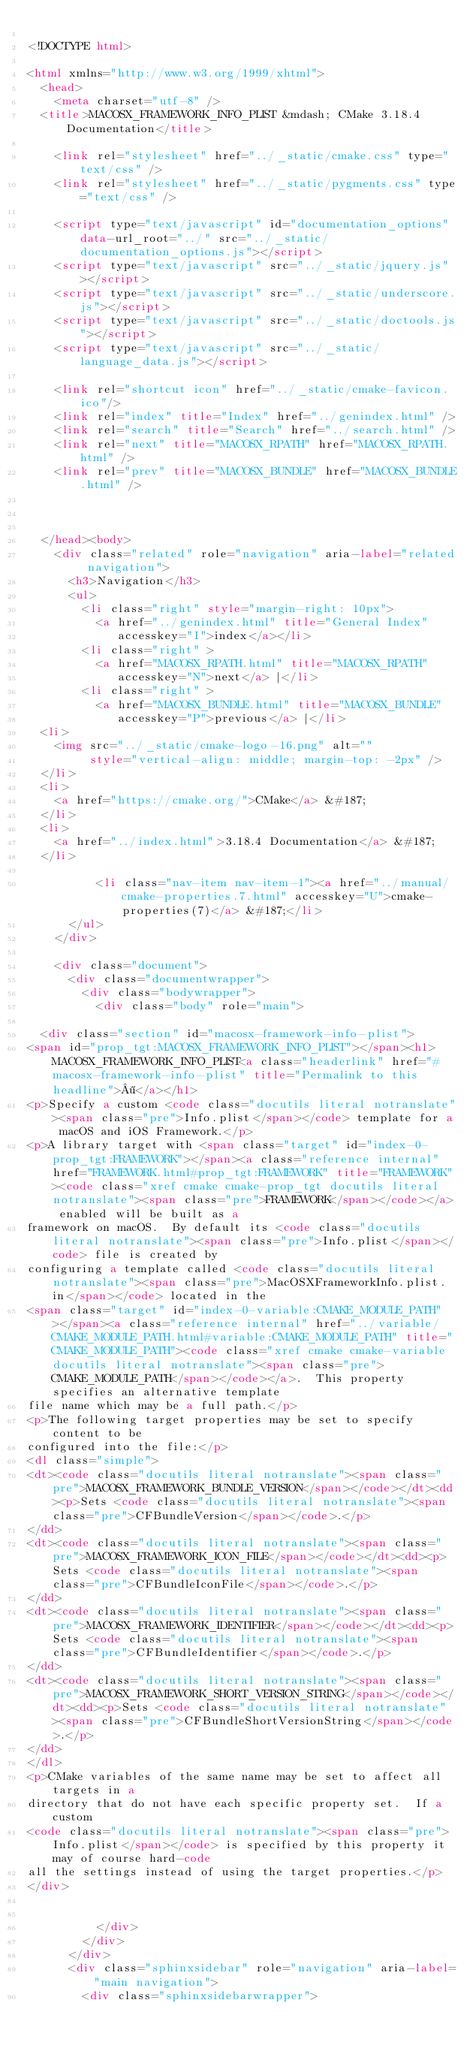Convert code to text. <code><loc_0><loc_0><loc_500><loc_500><_HTML_>
<!DOCTYPE html>

<html xmlns="http://www.w3.org/1999/xhtml">
  <head>
    <meta charset="utf-8" />
  <title>MACOSX_FRAMEWORK_INFO_PLIST &mdash; CMake 3.18.4 Documentation</title>

    <link rel="stylesheet" href="../_static/cmake.css" type="text/css" />
    <link rel="stylesheet" href="../_static/pygments.css" type="text/css" />
    
    <script type="text/javascript" id="documentation_options" data-url_root="../" src="../_static/documentation_options.js"></script>
    <script type="text/javascript" src="../_static/jquery.js"></script>
    <script type="text/javascript" src="../_static/underscore.js"></script>
    <script type="text/javascript" src="../_static/doctools.js"></script>
    <script type="text/javascript" src="../_static/language_data.js"></script>
    
    <link rel="shortcut icon" href="../_static/cmake-favicon.ico"/>
    <link rel="index" title="Index" href="../genindex.html" />
    <link rel="search" title="Search" href="../search.html" />
    <link rel="next" title="MACOSX_RPATH" href="MACOSX_RPATH.html" />
    <link rel="prev" title="MACOSX_BUNDLE" href="MACOSX_BUNDLE.html" />
  
 

  </head><body>
    <div class="related" role="navigation" aria-label="related navigation">
      <h3>Navigation</h3>
      <ul>
        <li class="right" style="margin-right: 10px">
          <a href="../genindex.html" title="General Index"
             accesskey="I">index</a></li>
        <li class="right" >
          <a href="MACOSX_RPATH.html" title="MACOSX_RPATH"
             accesskey="N">next</a> |</li>
        <li class="right" >
          <a href="MACOSX_BUNDLE.html" title="MACOSX_BUNDLE"
             accesskey="P">previous</a> |</li>
  <li>
    <img src="../_static/cmake-logo-16.png" alt=""
         style="vertical-align: middle; margin-top: -2px" />
  </li>
  <li>
    <a href="https://cmake.org/">CMake</a> &#187;
  </li>
  <li>
    <a href="../index.html">3.18.4 Documentation</a> &#187;
  </li>

          <li class="nav-item nav-item-1"><a href="../manual/cmake-properties.7.html" accesskey="U">cmake-properties(7)</a> &#187;</li> 
      </ul>
    </div>  

    <div class="document">
      <div class="documentwrapper">
        <div class="bodywrapper">
          <div class="body" role="main">
            
  <div class="section" id="macosx-framework-info-plist">
<span id="prop_tgt:MACOSX_FRAMEWORK_INFO_PLIST"></span><h1>MACOSX_FRAMEWORK_INFO_PLIST<a class="headerlink" href="#macosx-framework-info-plist" title="Permalink to this headline">¶</a></h1>
<p>Specify a custom <code class="docutils literal notranslate"><span class="pre">Info.plist</span></code> template for a macOS and iOS Framework.</p>
<p>A library target with <span class="target" id="index-0-prop_tgt:FRAMEWORK"></span><a class="reference internal" href="FRAMEWORK.html#prop_tgt:FRAMEWORK" title="FRAMEWORK"><code class="xref cmake cmake-prop_tgt docutils literal notranslate"><span class="pre">FRAMEWORK</span></code></a> enabled will be built as a
framework on macOS.  By default its <code class="docutils literal notranslate"><span class="pre">Info.plist</span></code> file is created by
configuring a template called <code class="docutils literal notranslate"><span class="pre">MacOSXFrameworkInfo.plist.in</span></code> located in the
<span class="target" id="index-0-variable:CMAKE_MODULE_PATH"></span><a class="reference internal" href="../variable/CMAKE_MODULE_PATH.html#variable:CMAKE_MODULE_PATH" title="CMAKE_MODULE_PATH"><code class="xref cmake cmake-variable docutils literal notranslate"><span class="pre">CMAKE_MODULE_PATH</span></code></a>.  This property specifies an alternative template
file name which may be a full path.</p>
<p>The following target properties may be set to specify content to be
configured into the file:</p>
<dl class="simple">
<dt><code class="docutils literal notranslate"><span class="pre">MACOSX_FRAMEWORK_BUNDLE_VERSION</span></code></dt><dd><p>Sets <code class="docutils literal notranslate"><span class="pre">CFBundleVersion</span></code>.</p>
</dd>
<dt><code class="docutils literal notranslate"><span class="pre">MACOSX_FRAMEWORK_ICON_FILE</span></code></dt><dd><p>Sets <code class="docutils literal notranslate"><span class="pre">CFBundleIconFile</span></code>.</p>
</dd>
<dt><code class="docutils literal notranslate"><span class="pre">MACOSX_FRAMEWORK_IDENTIFIER</span></code></dt><dd><p>Sets <code class="docutils literal notranslate"><span class="pre">CFBundleIdentifier</span></code>.</p>
</dd>
<dt><code class="docutils literal notranslate"><span class="pre">MACOSX_FRAMEWORK_SHORT_VERSION_STRING</span></code></dt><dd><p>Sets <code class="docutils literal notranslate"><span class="pre">CFBundleShortVersionString</span></code>.</p>
</dd>
</dl>
<p>CMake variables of the same name may be set to affect all targets in a
directory that do not have each specific property set.  If a custom
<code class="docutils literal notranslate"><span class="pre">Info.plist</span></code> is specified by this property it may of course hard-code
all the settings instead of using the target properties.</p>
</div>


          </div>
        </div>
      </div>
      <div class="sphinxsidebar" role="navigation" aria-label="main navigation">
        <div class="sphinxsidebarwrapper"></code> 